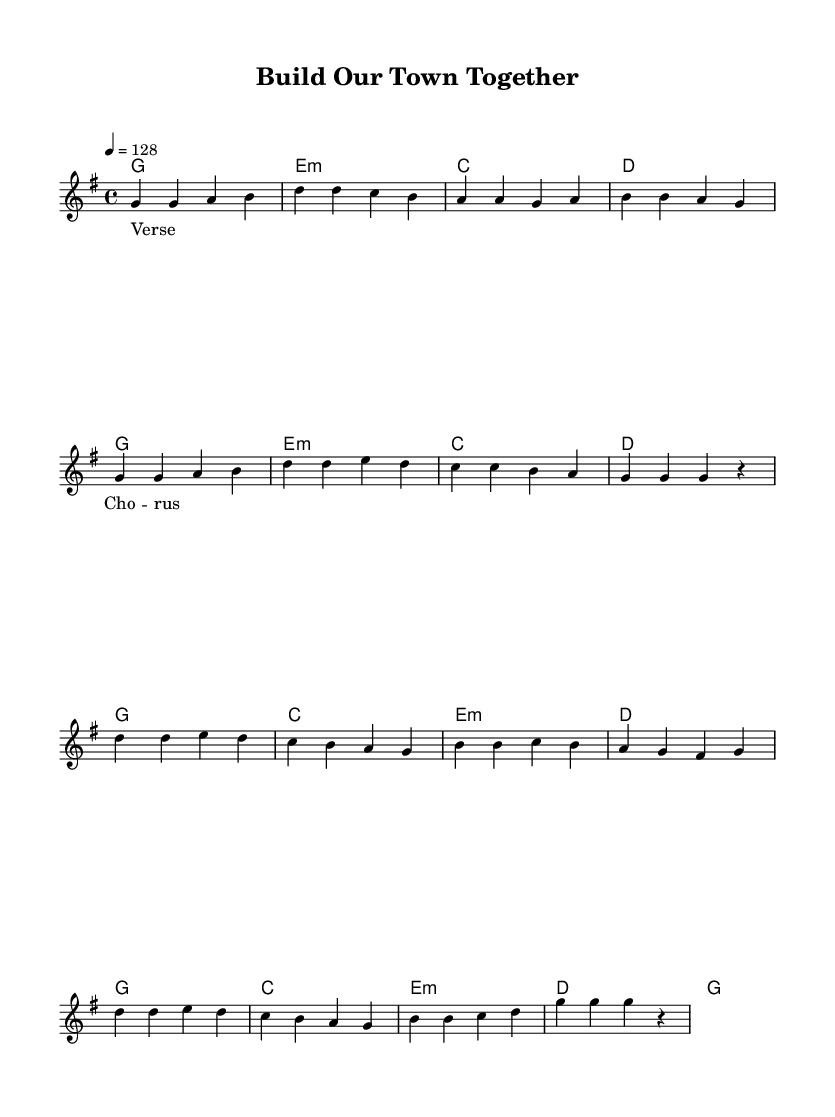What is the key signature of this music? The key signature is G major, which has one sharp (F#). This can be determined by looking at the key signature notation at the beginning of the score, immediately following the clef.
Answer: G major What is the time signature of this music? The time signature is 4/4, which means there are four beats in each measure and a quarter note receives one beat. This is indicated at the beginning of the score, next to the key signature.
Answer: 4/4 What is the tempo marking for this piece? The tempo marking is 128 beats per minute, which is indicated by the number '4 = 128' following the tempo directive. This tells us how fast the piece should be played.
Answer: 128 How many measures are present in the verse? The verse consists of eight measures, as can be seen by counting the vertical bar lines that separate the measures within that section. Each group of notes between the bar lines represents one measure.
Answer: 8 What type of chords are primarily used in the chorus? The chorus uses major and minor chords, specifically G major, C major, and E minor, as identified by the chord symbols written above the melody in that section. This chord variety is common in K-Pop for creating emotional contrast.
Answer: Major and minor What is the overall theme represented in the lyrics? The overall theme is about community and collaboration, which is reflected in the title "Build Our Town Together." K-Pop frequently emphasizes social messages, and this piece likely promotes civic responsibility.
Answer: Community service What is the role of the "e:m" chord in the song structure? The "e:m" chord appears as the third chord in both the verse and the chorus, suggesting an emotional pivot point, common in K-Pop structure to add depth and complexity to the harmony while maintaining engagement.
Answer: Emotional pivot 